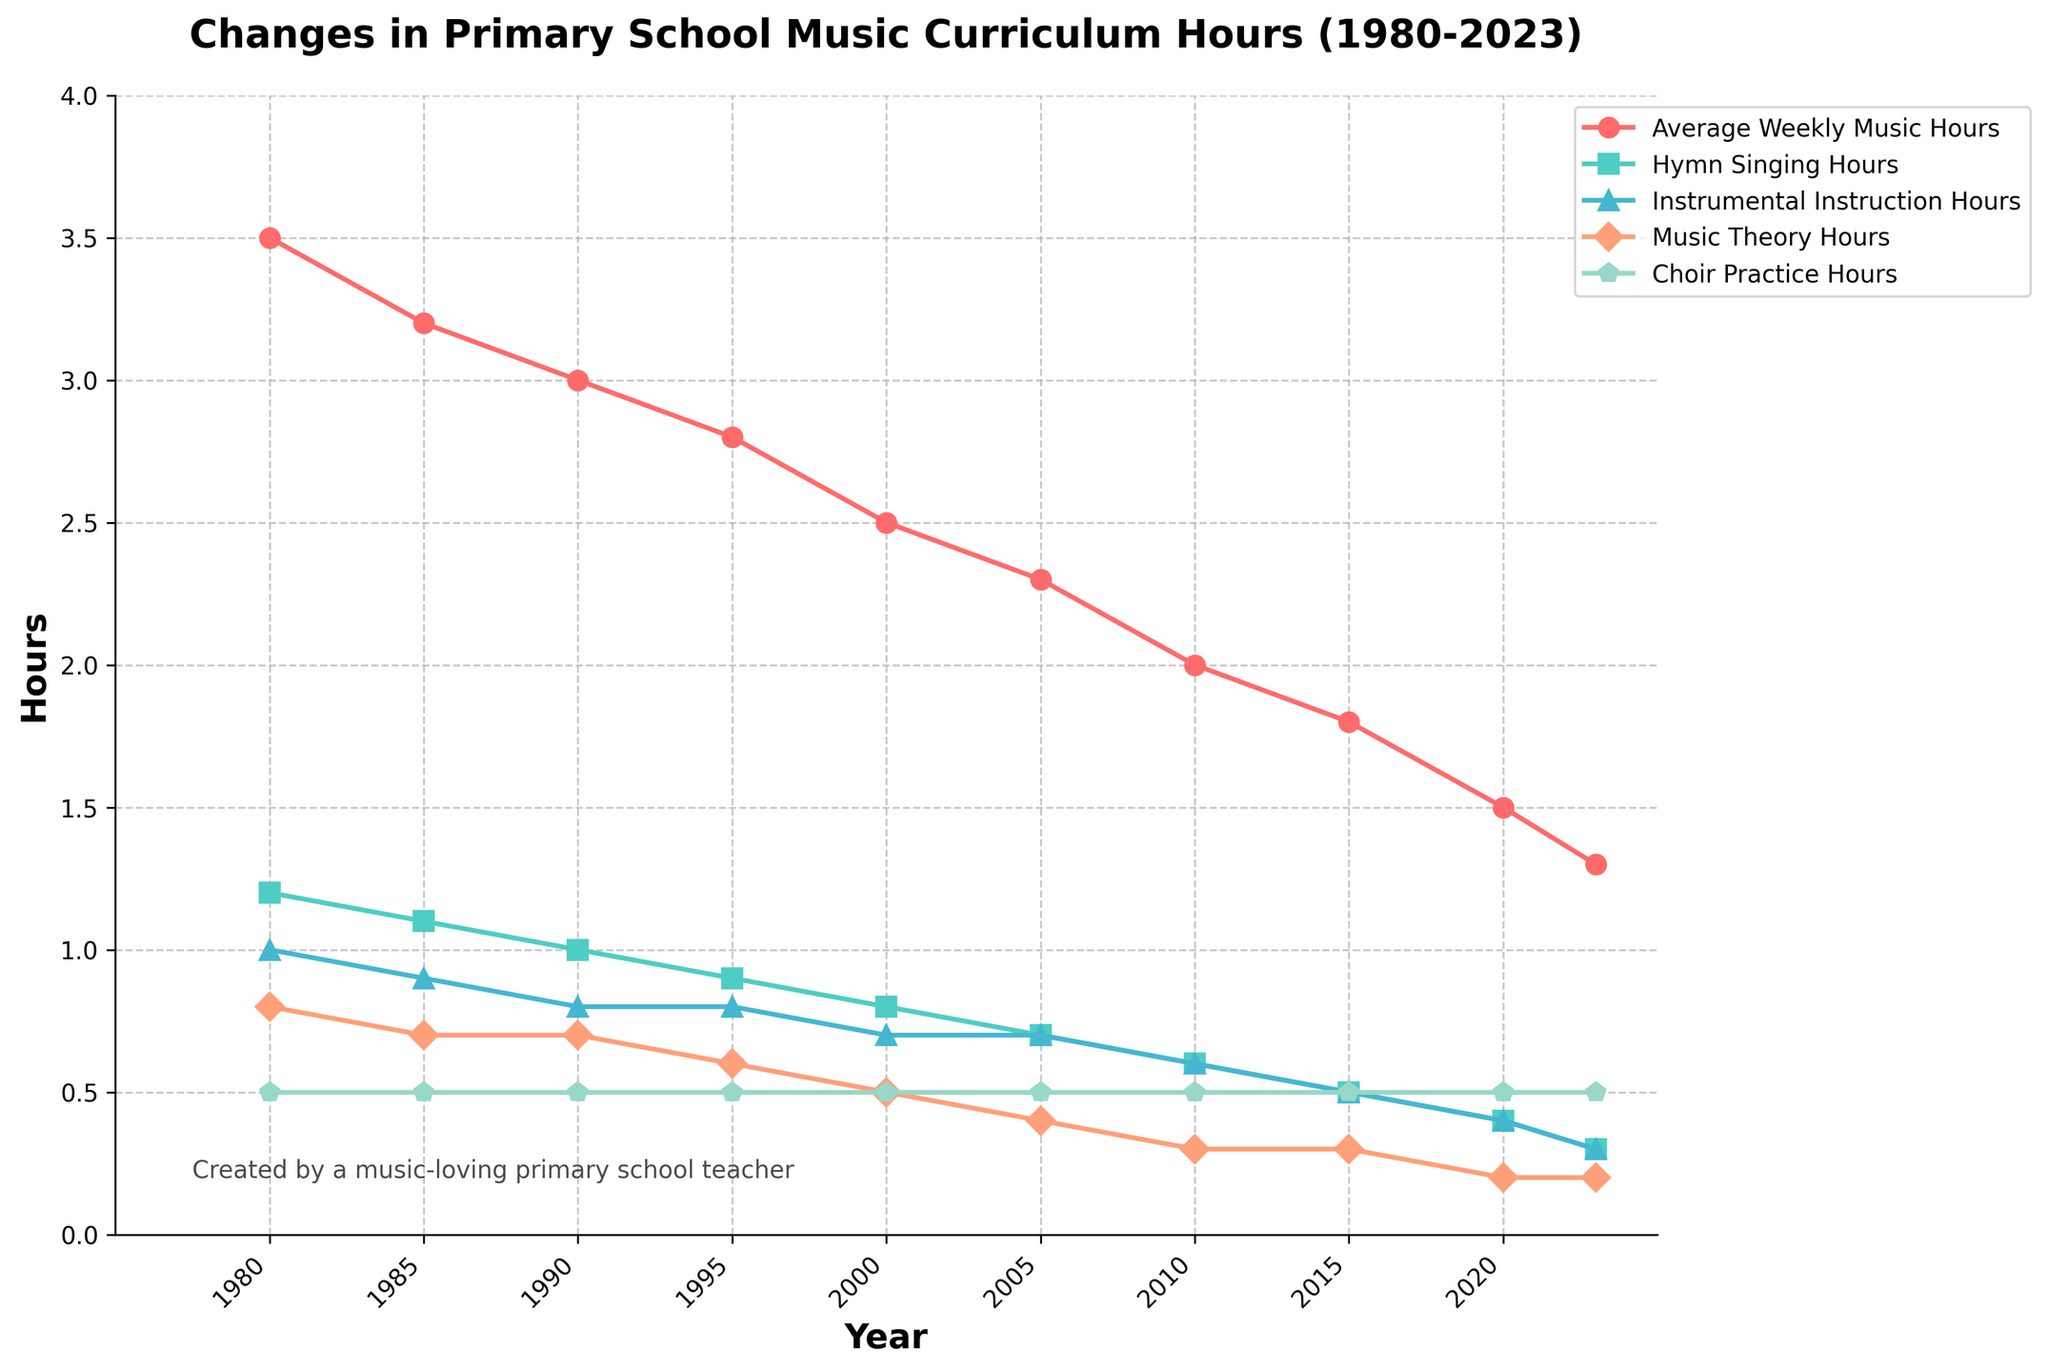Which musical activity saw the most significant decrease in hours from 1980 to 2023? We examine the data and compare the differences between 1980 and 2023 for each activity. Hymn Singing Hours decreased from 1.2 to 0.3, Instrumental Instruction Hours from 1.0 to 0.3, Music Theory Hours from 0.8 to 0.2, while Choir Practice Hours stayed constant at 0.5. The largest decrease is in Hymn Singing Hours.
Answer: Hymn Singing Hours What is the overall trend in average weekly music hours from 1980 to 2023? To determine the overall trend, we observe the slope of the line for Average Weekly Music Hours over the years. The line consistently declines from 3.5 hours in 1980 to 1.3 hours in 2023, indicating a decreasing trend.
Answer: Decreasing Compare the Change in Hymn Singing Hours to Instrumental Instruction Hours between 1980 and 2023. We calculate the difference between 1980 and 2023 for both Hymn Singing and Instrumental Instruction Hours. Both Hymn Singing Hours decrease from 1.2 to 0.3 and Instrumental Instruction Hours from 1.0 to 0.3. The decrease is 0.9 for Hymn Singing Hours and 0.7 for Instrumental Instruction Hours. Hymn Singing Hours had a larger decrease.
Answer: Hymn Singing Hours decrease more How did Music Theory Hours change from 2000 to 2023? We look at the points for Music Theory Hours at 2000 and 2023. In 2000, it was 0.5 hours, and in 2023, it is 0.2 hours. The difference is 0.5 - 0.2 = 0.3 hours. It indicates a decrease of 0.3 hours.
Answer: Decreased by 0.3 hours Which musical activity remained stable over the years? Observing the graph, we notice that Choir Practice Hours show no change and stay at 0.5 hours throughout the years.
Answer: Choir Practice Hours What was the average of Average Weekly Music Hours from 1980 to 2023? We sum up the Average Weekly Music Hours for all the years (3.5 + 3.2 + 3.0 + 2.8 + 2.5 + 2.3 + 2.0 + 1.8 + 1.5 + 1.3 = 23.9) and divide by the number of years (10). The average is 23.9 / 10 = 2.39.
Answer: 2.39 hours Identify the year with the biggest drop in Hymn Singing Hours. By checking the data, we see the biggest drop occurs between 1980 (1.2 hours) and 1985 (1.1 hours), but declines between other consecutive years are equal. The initial drop from 1980 to 1985 is the largest unique drop.
Answer: 1980 to 1985 Compare Choir Practice Hours in 1980 and 2023. By directly looking at the graph, we see Choir Practice Hours remain constant at 0.5 hours in both 1980 and 2023. There is no change in hours.
Answer: No Change When was the first time that Instrumental Instruction Hours dropped below 0.5 hours per week? By referring to the plot, we can see that Instrumental Instruction Hours remain above 0.5 until around 2015 when they reach or slightly drop to 0.5 hours.
Answer: Around 2015 Which activity had the least amount of time allocated consistently across the years? Referring to the graph, the least amount of time consistently allocated is to Choir Practice Hours, which remained at 0.5 hours every year from 1980 to 2023.
Answer: Choir Practice Hours 